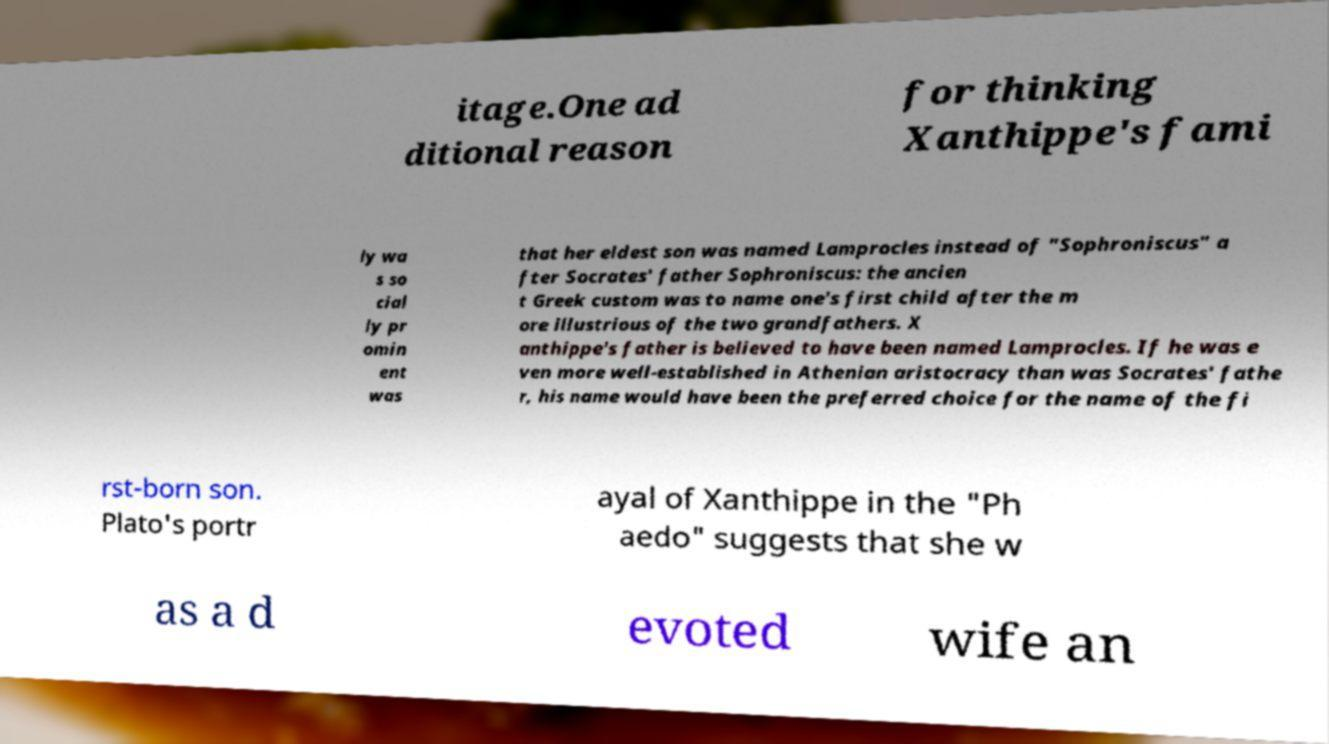What messages or text are displayed in this image? I need them in a readable, typed format. itage.One ad ditional reason for thinking Xanthippe's fami ly wa s so cial ly pr omin ent was that her eldest son was named Lamprocles instead of "Sophroniscus" a fter Socrates' father Sophroniscus: the ancien t Greek custom was to name one's first child after the m ore illustrious of the two grandfathers. X anthippe's father is believed to have been named Lamprocles. If he was e ven more well-established in Athenian aristocracy than was Socrates' fathe r, his name would have been the preferred choice for the name of the fi rst-born son. Plato's portr ayal of Xanthippe in the "Ph aedo" suggests that she w as a d evoted wife an 